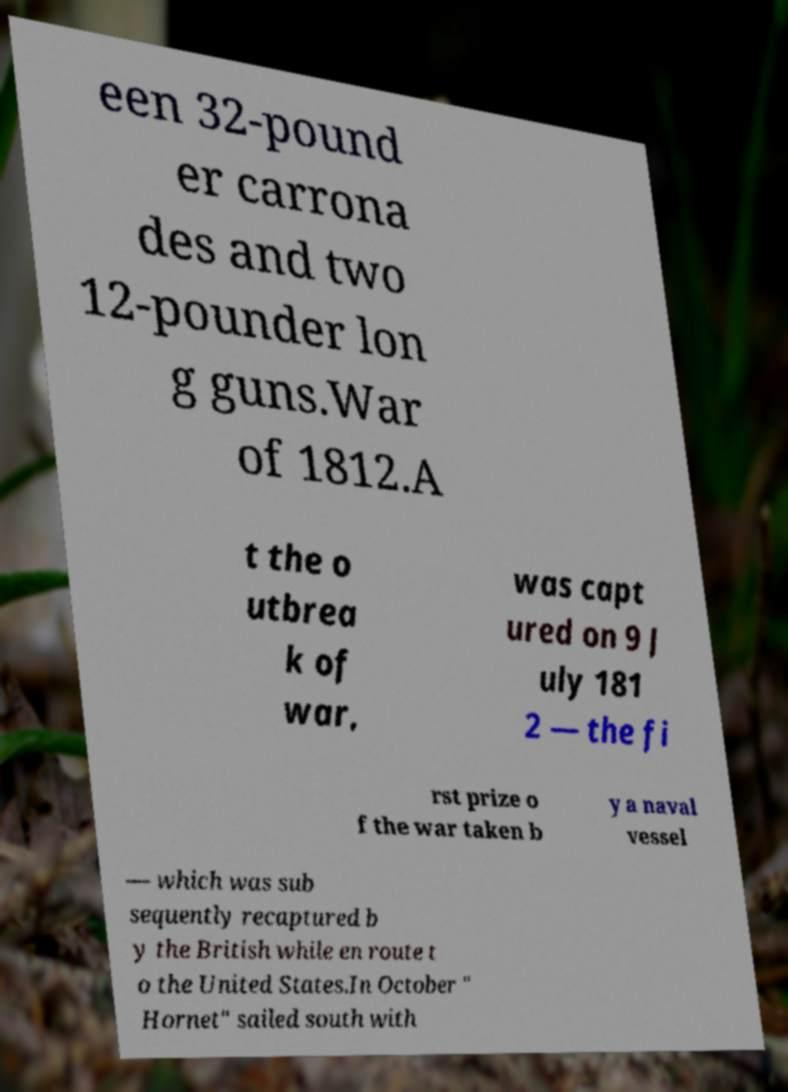Please identify and transcribe the text found in this image. een 32-pound er carrona des and two 12-pounder lon g guns.War of 1812.A t the o utbrea k of war, was capt ured on 9 J uly 181 2 — the fi rst prize o f the war taken b y a naval vessel — which was sub sequently recaptured b y the British while en route t o the United States.In October " Hornet" sailed south with 